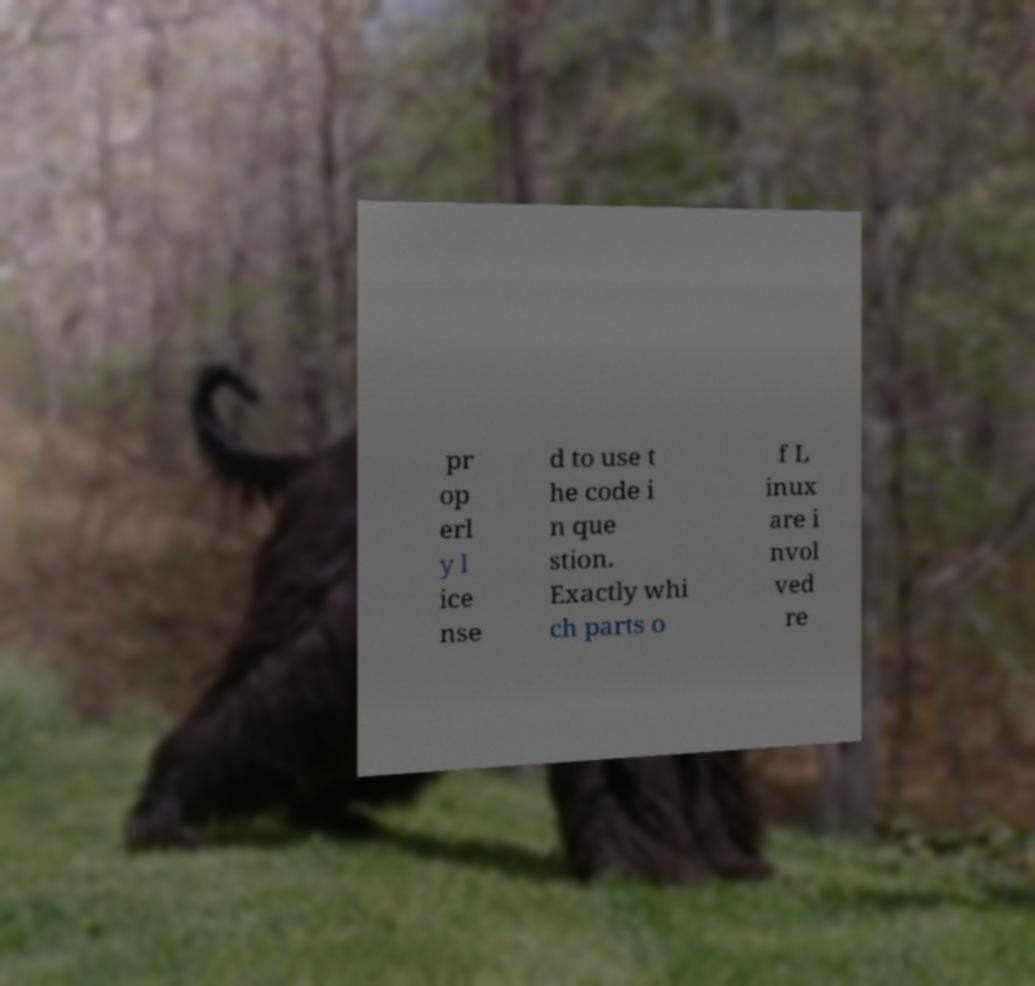Could you assist in decoding the text presented in this image and type it out clearly? pr op erl y l ice nse d to use t he code i n que stion. Exactly whi ch parts o f L inux are i nvol ved re 